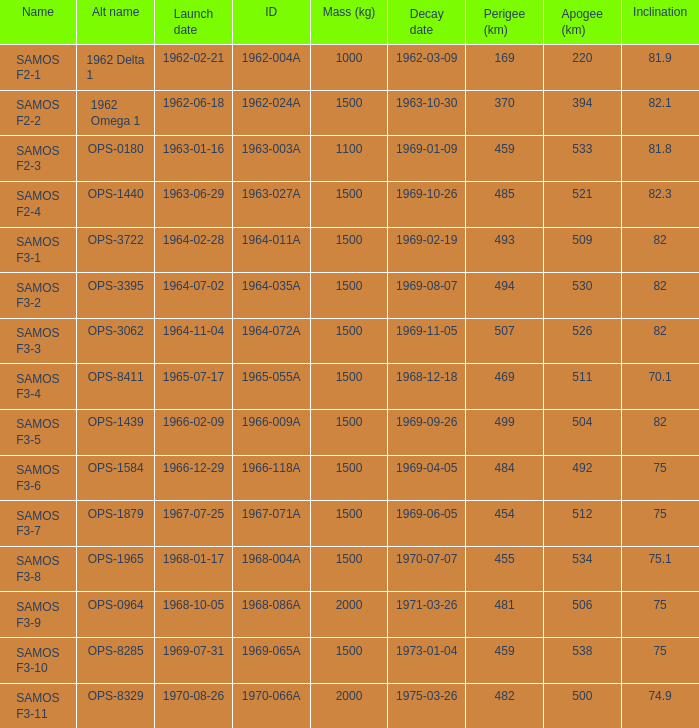With ops-1584 as the alt name, what is the inclination? 75.0. 